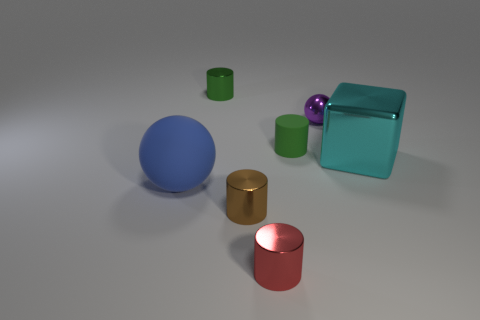What could be the purpose of these objects? These objects seem like they might be used for a color and size comparison exercise or perhaps as part of a 3D modeling and rendering demonstration, showcasing different shapes, materials, and lighting effects. 